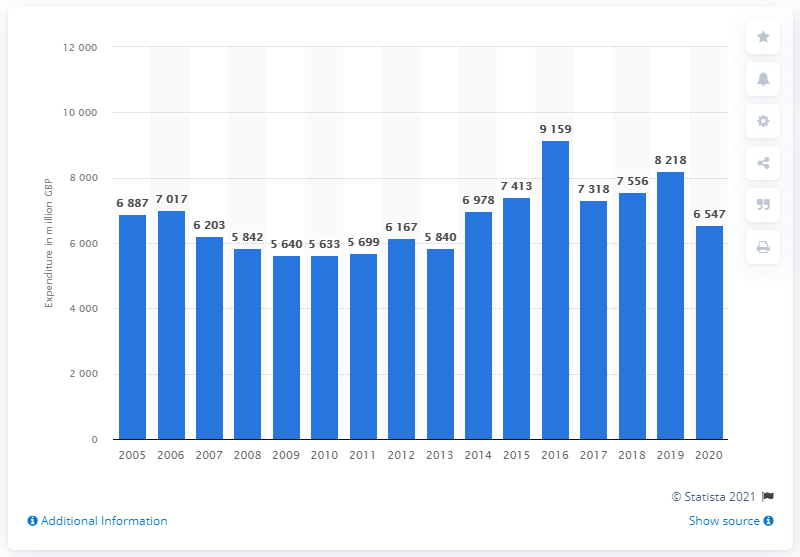Point out several critical features in this image. In the year 2005, the total annual expenditure on jewelry, clocks, and watches in the United Kingdom commenced. In 2020, households in the United Kingdom purchased a total of 6,547 British pounds worth of jewelry. 